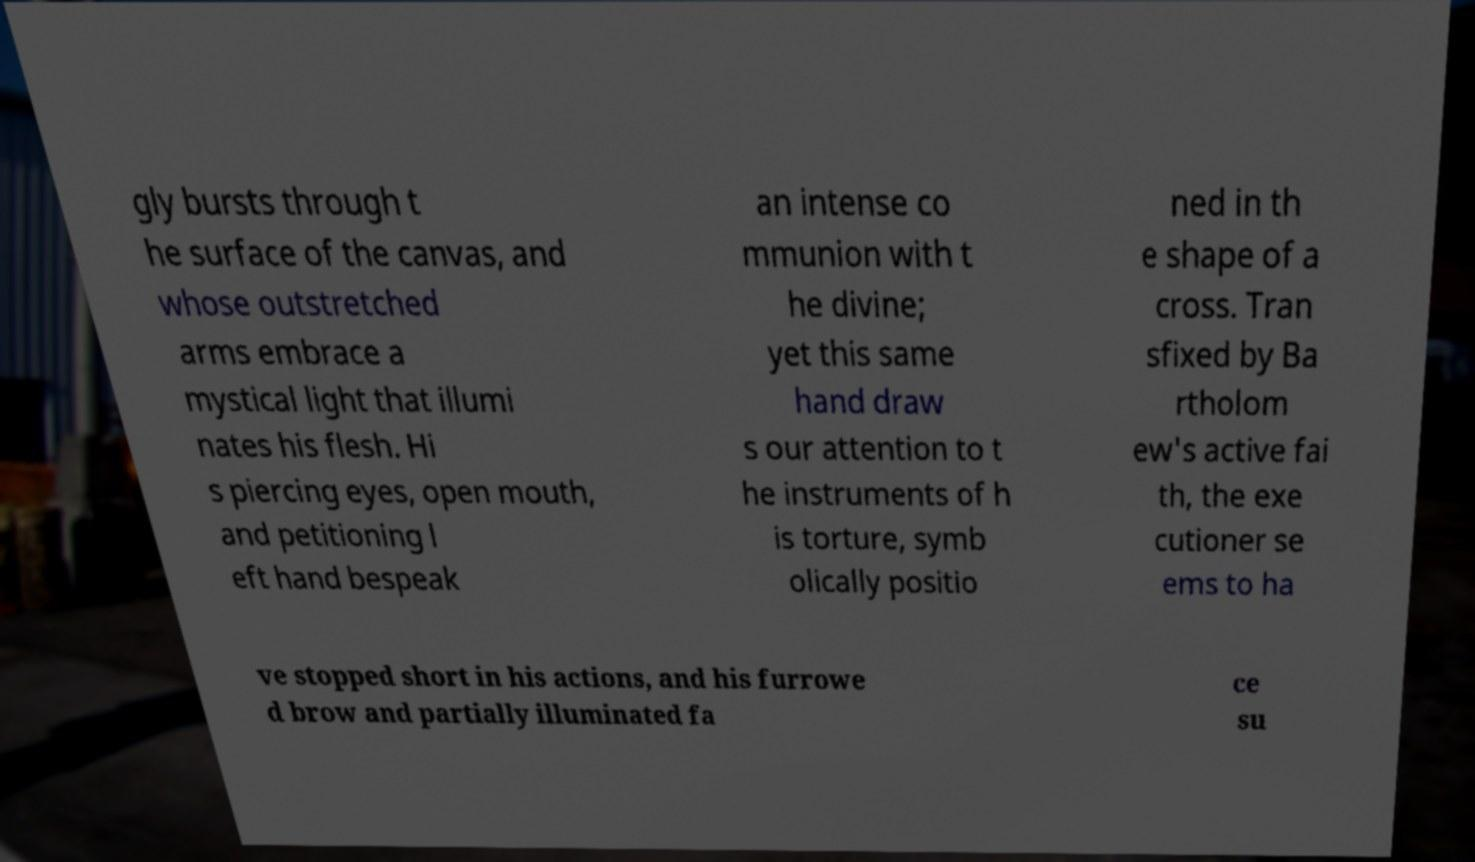What messages or text are displayed in this image? I need them in a readable, typed format. gly bursts through t he surface of the canvas, and whose outstretched arms embrace a mystical light that illumi nates his flesh. Hi s piercing eyes, open mouth, and petitioning l eft hand bespeak an intense co mmunion with t he divine; yet this same hand draw s our attention to t he instruments of h is torture, symb olically positio ned in th e shape of a cross. Tran sfixed by Ba rtholom ew's active fai th, the exe cutioner se ems to ha ve stopped short in his actions, and his furrowe d brow and partially illuminated fa ce su 